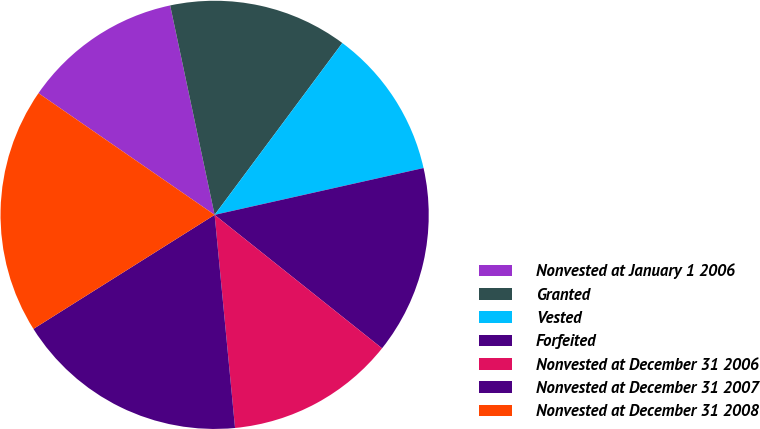Convert chart to OTSL. <chart><loc_0><loc_0><loc_500><loc_500><pie_chart><fcel>Nonvested at January 1 2006<fcel>Granted<fcel>Vested<fcel>Forfeited<fcel>Nonvested at December 31 2006<fcel>Nonvested at December 31 2007<fcel>Nonvested at December 31 2008<nl><fcel>12.05%<fcel>13.5%<fcel>11.32%<fcel>14.22%<fcel>12.77%<fcel>17.58%<fcel>18.56%<nl></chart> 